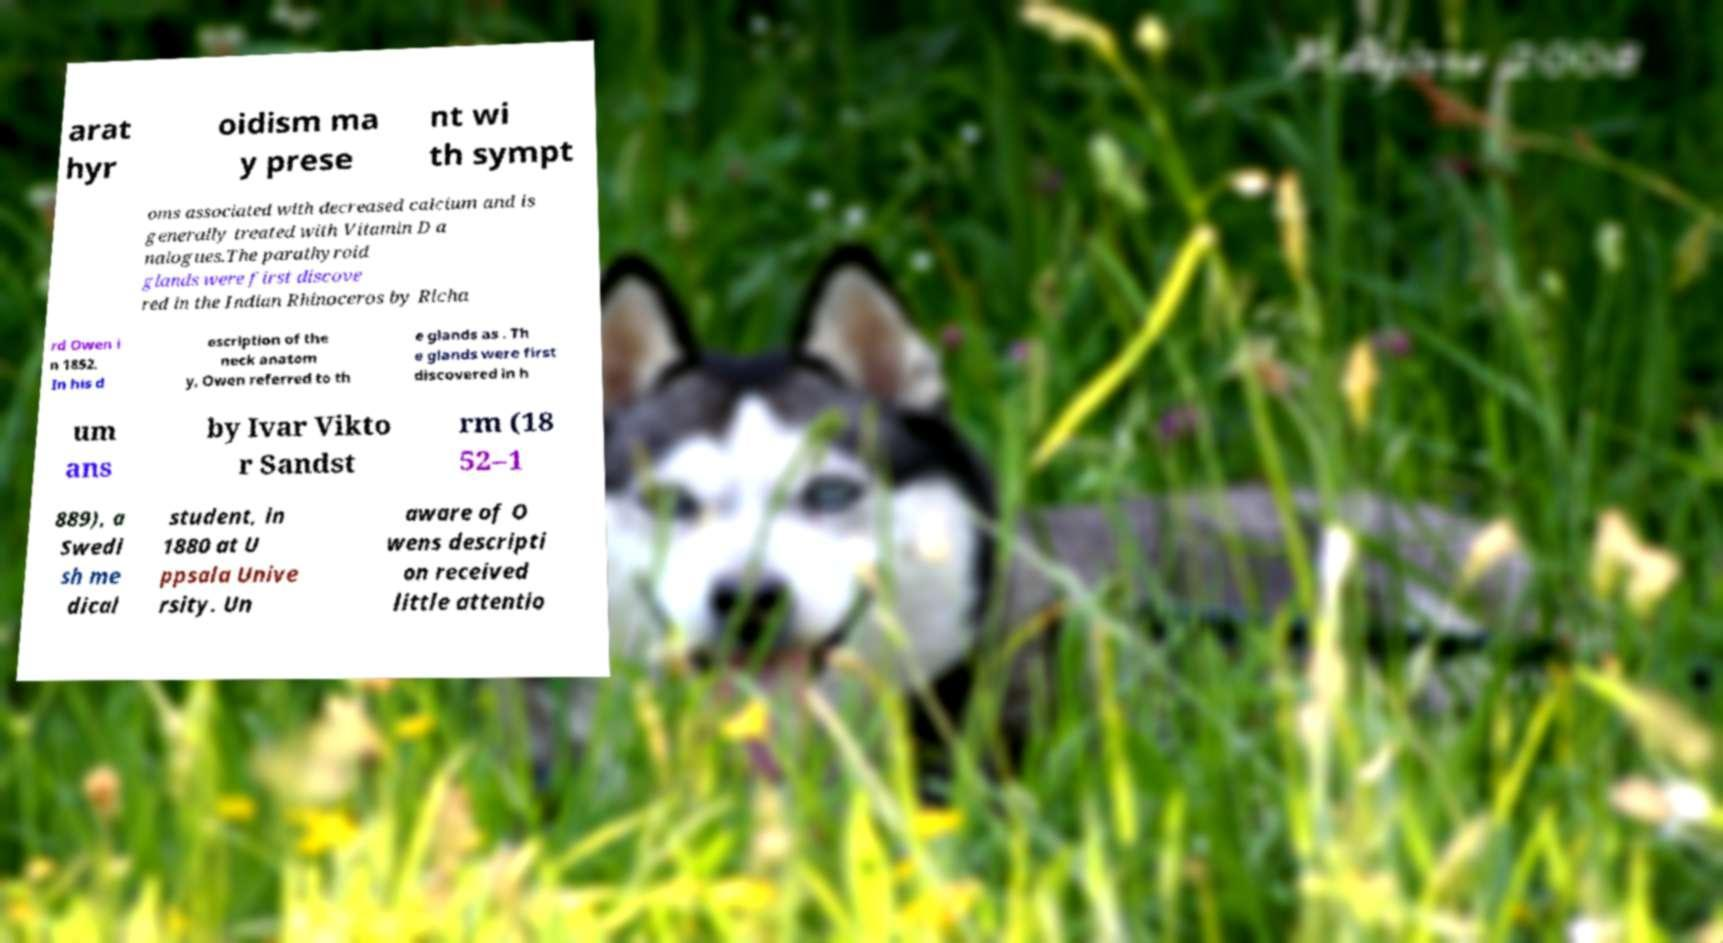There's text embedded in this image that I need extracted. Can you transcribe it verbatim? arat hyr oidism ma y prese nt wi th sympt oms associated with decreased calcium and is generally treated with Vitamin D a nalogues.The parathyroid glands were first discove red in the Indian Rhinoceros by Richa rd Owen i n 1852. In his d escription of the neck anatom y, Owen referred to th e glands as . Th e glands were first discovered in h um ans by Ivar Vikto r Sandst rm (18 52–1 889), a Swedi sh me dical student, in 1880 at U ppsala Unive rsity. Un aware of O wens descripti on received little attentio 